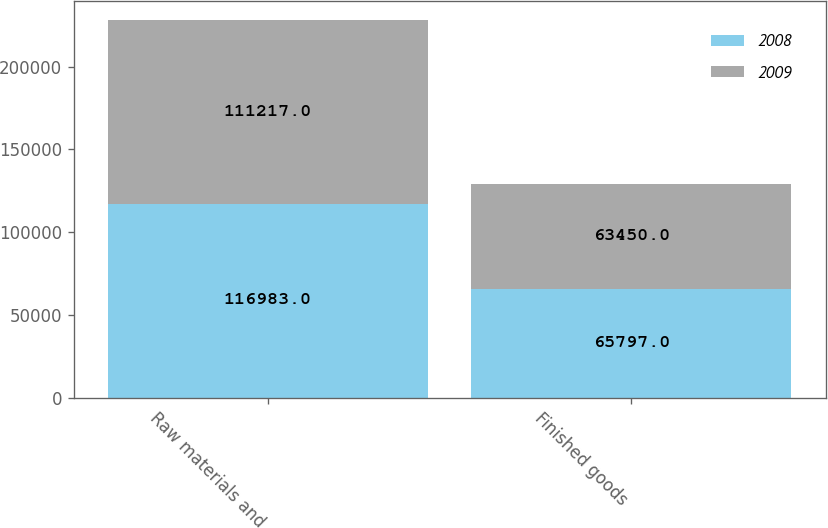Convert chart to OTSL. <chart><loc_0><loc_0><loc_500><loc_500><stacked_bar_chart><ecel><fcel>Raw materials and<fcel>Finished goods<nl><fcel>2008<fcel>116983<fcel>65797<nl><fcel>2009<fcel>111217<fcel>63450<nl></chart> 